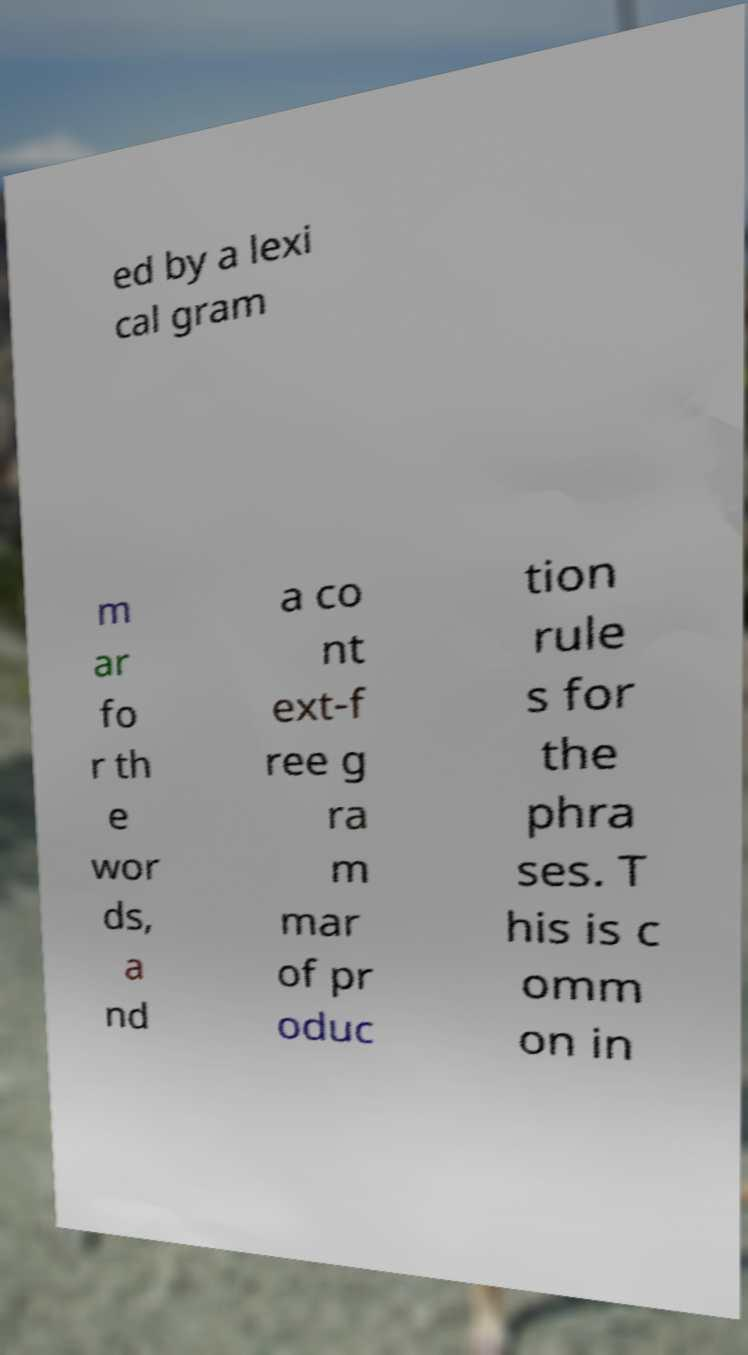Could you assist in decoding the text presented in this image and type it out clearly? ed by a lexi cal gram m ar fo r th e wor ds, a nd a co nt ext-f ree g ra m mar of pr oduc tion rule s for the phra ses. T his is c omm on in 